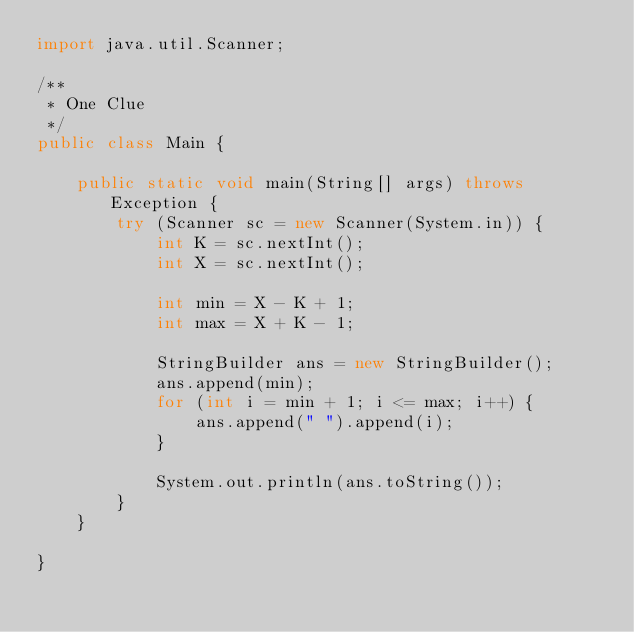<code> <loc_0><loc_0><loc_500><loc_500><_Java_>import java.util.Scanner;

/**
 * One Clue
 */
public class Main {

    public static void main(String[] args) throws Exception {
        try (Scanner sc = new Scanner(System.in)) {
            int K = sc.nextInt();
            int X = sc.nextInt();

            int min = X - K + 1;
            int max = X + K - 1;

            StringBuilder ans = new StringBuilder();
            ans.append(min);
            for (int i = min + 1; i <= max; i++) {
                ans.append(" ").append(i);
            }

            System.out.println(ans.toString());
        }
    }

}
</code> 